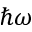<formula> <loc_0><loc_0><loc_500><loc_500>\hbar { \omega }</formula> 